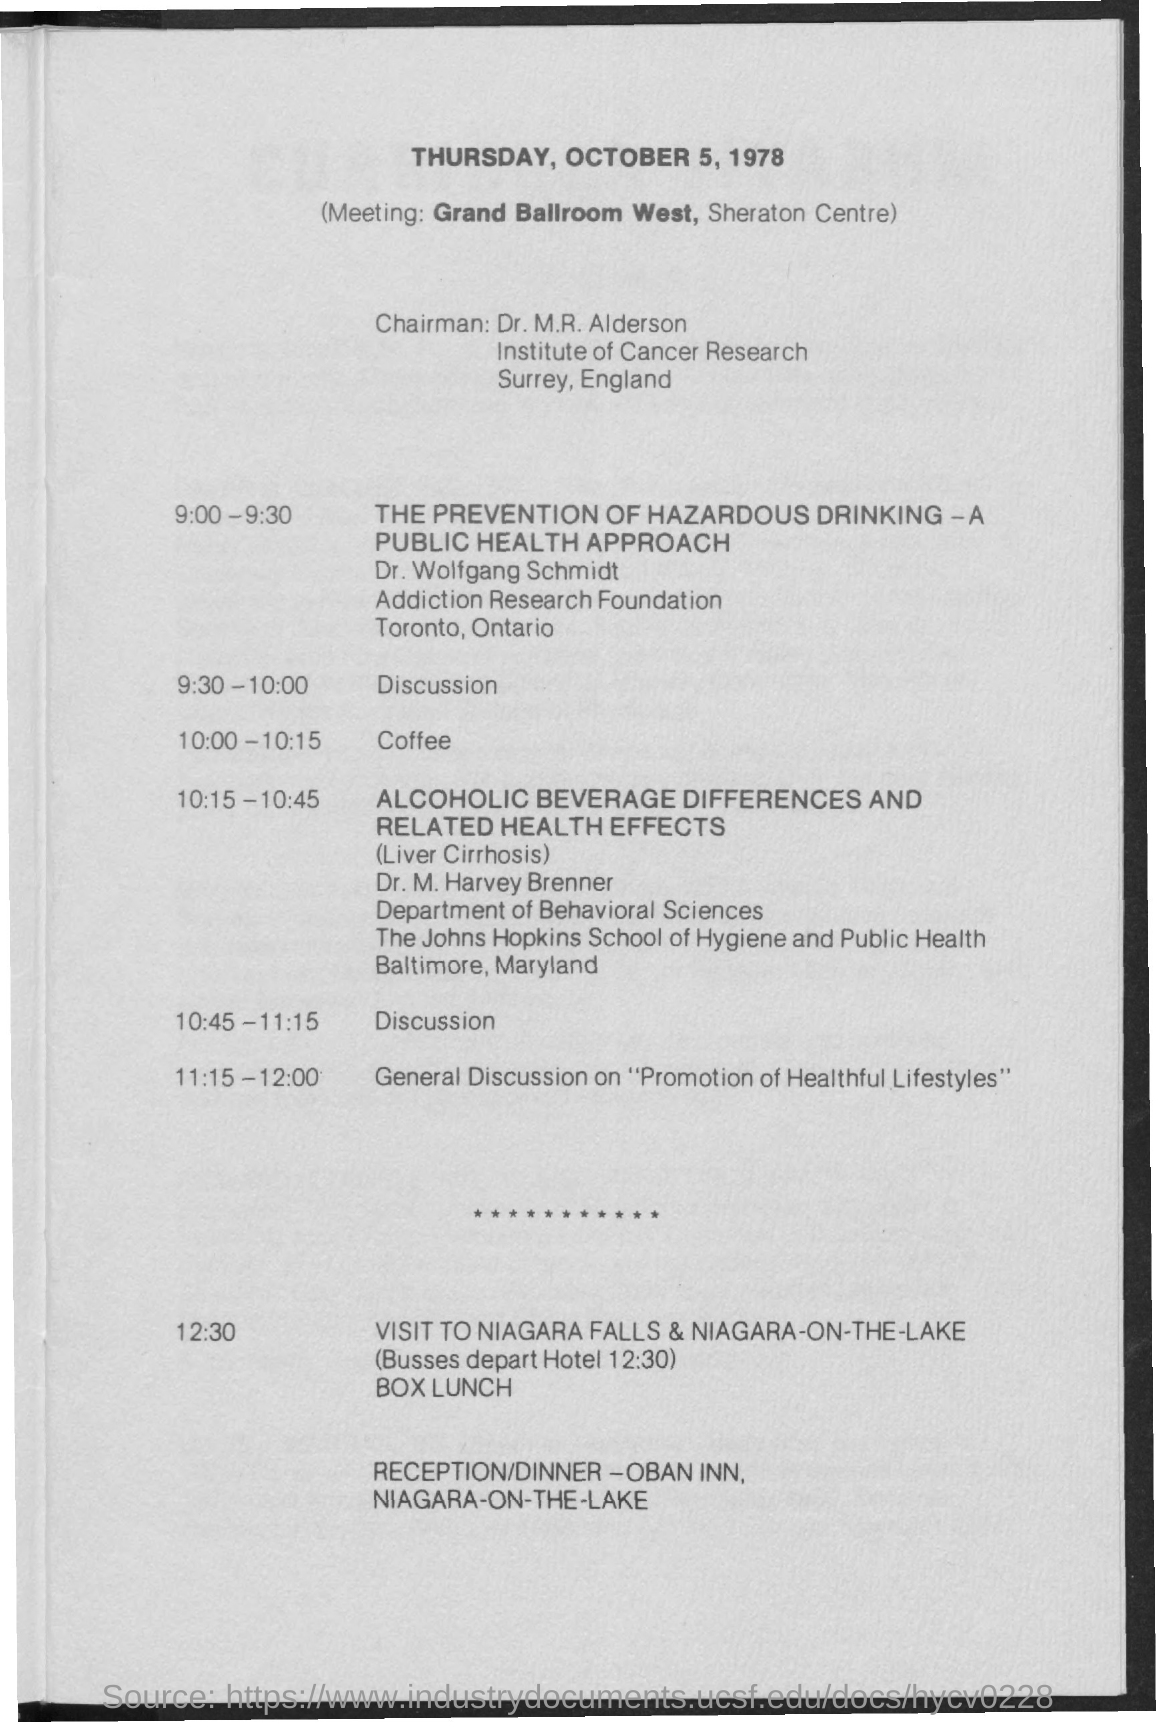When is the Meeting?
Provide a short and direct response. Thursday, October 5, 1978. Where is the meeting?
Your response must be concise. Grand Ballroom West, Sheraton Centre. Who is the Chairman?
Keep it short and to the point. Dr. M.R. Alderson. When is the first "Discussion" of the day?
Offer a very short reply. 9:30-10:00. When is the coffee?
Provide a succinct answer. 10:00 - 10:15. When is the General discussion on "Promotion of Healthful Lifestyles"?
Your answer should be compact. 11:15-12:00. 